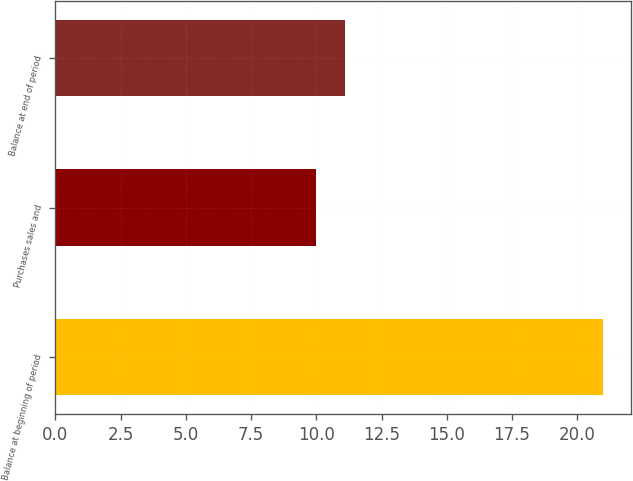<chart> <loc_0><loc_0><loc_500><loc_500><bar_chart><fcel>Balance at beginning of period<fcel>Purchases sales and<fcel>Balance at end of period<nl><fcel>21<fcel>10<fcel>11.1<nl></chart> 